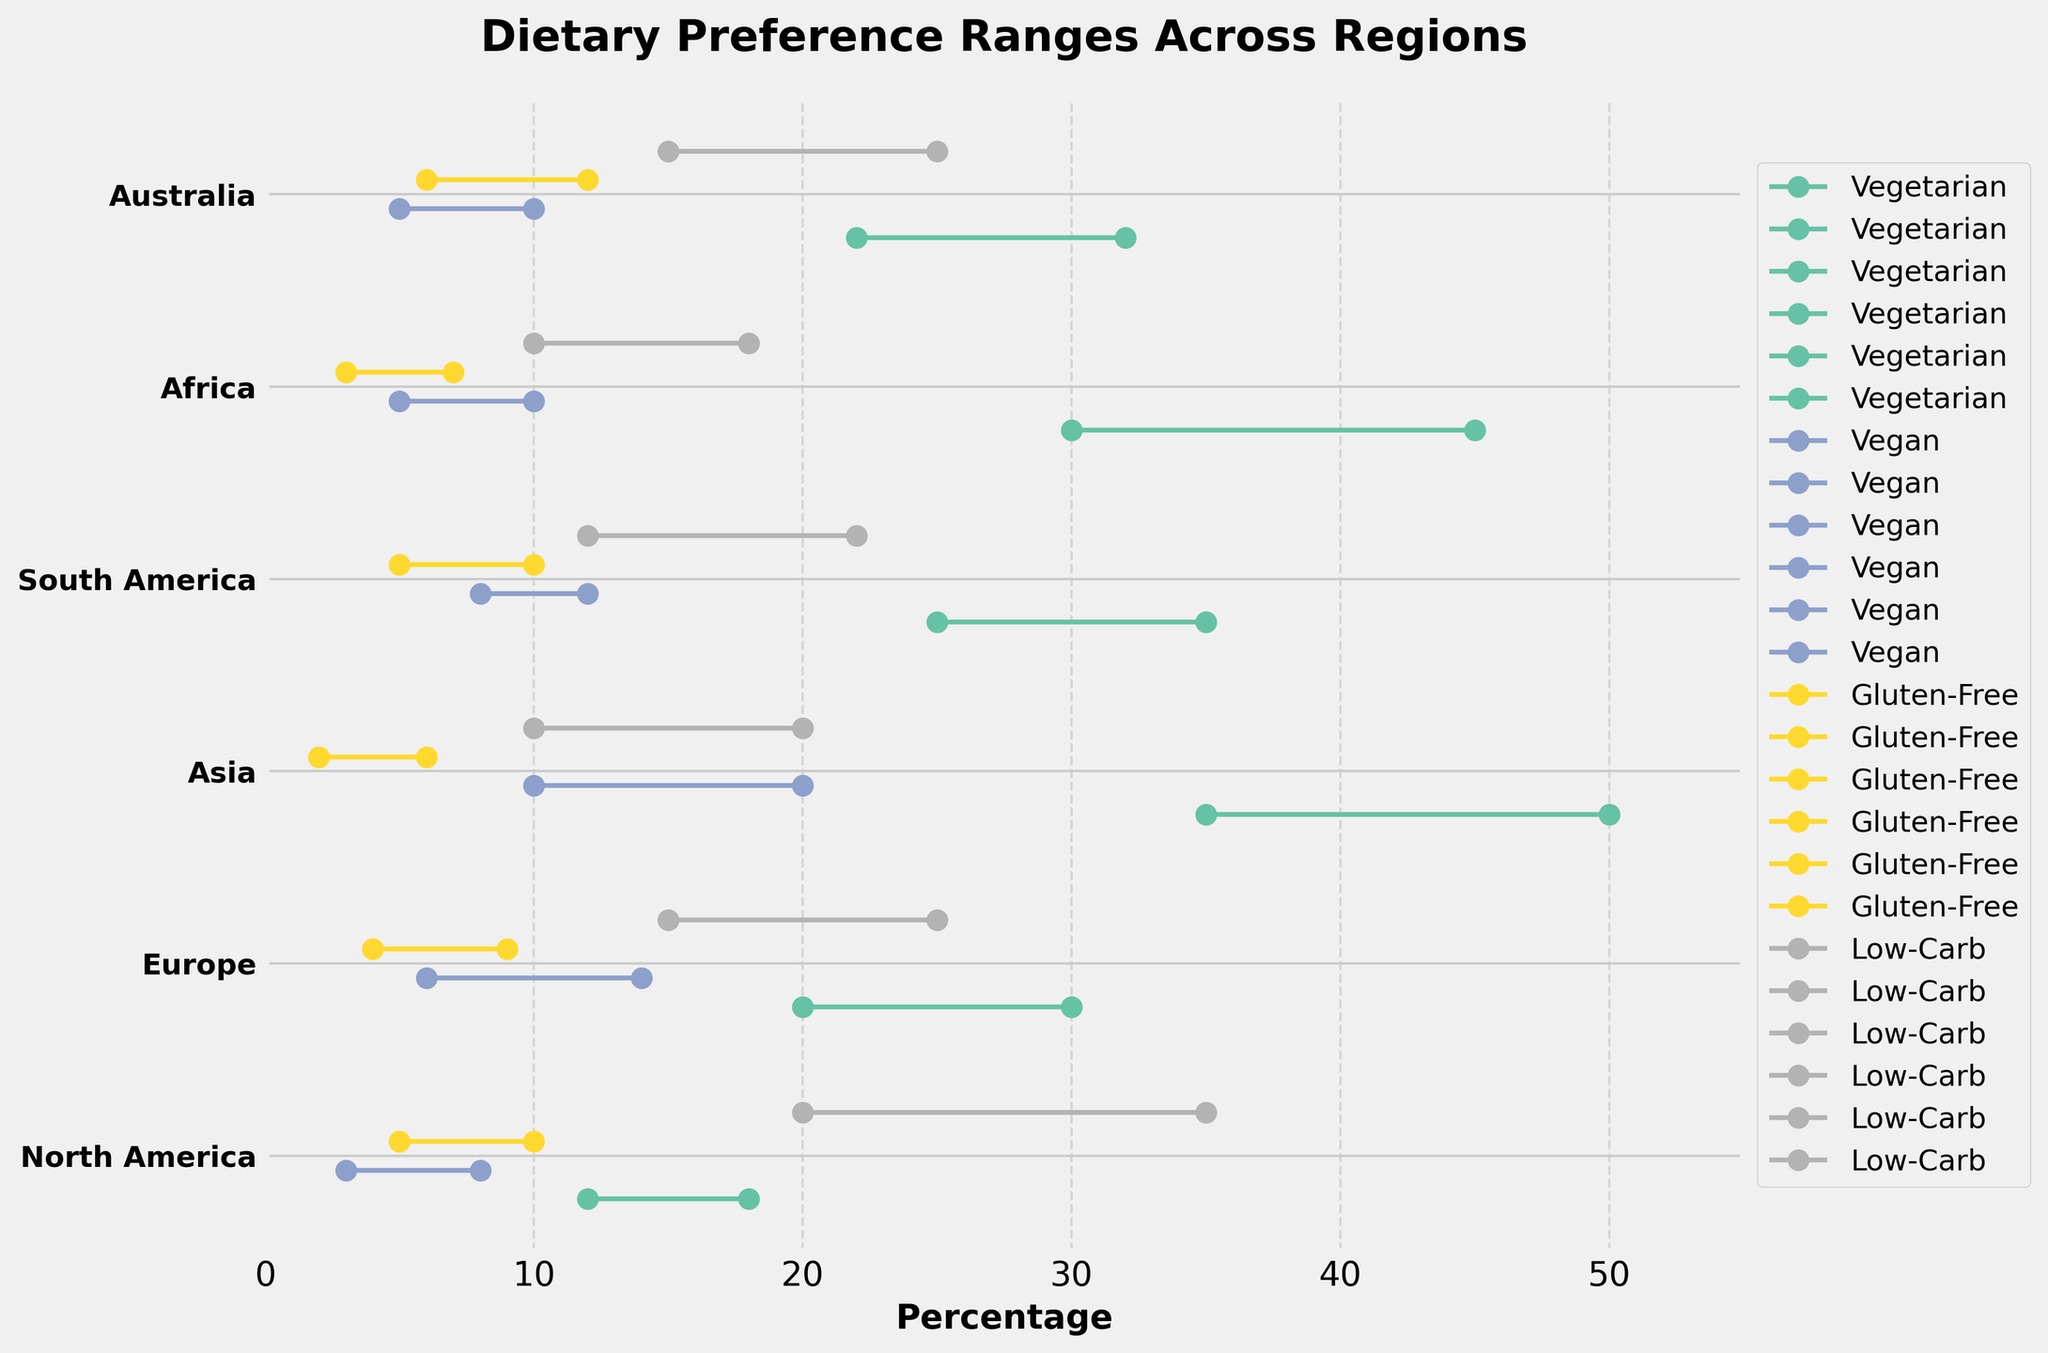What is the title of the plot? The title of the plot is located at the top and is typically the largest and boldest text on the image. This provides an overview of what the plot is about.
Answer: Dietary Preference Ranges Across Regions Which region has the highest maximum percentage for vegetarian dietary preferences? From the plot, take each region's dot plot section and compare the end point of the vegetarian preference bars. The bar in the Asia region ends at the highest percentage.
Answer: Asia What is the percentage range for gluten-free preferences in Europe? Locate the section of the plot corresponding to Europe. Identify the gluten-free row and read the minimum and maximum percentages indicated by the starting and ending points of the bar.
Answer: 4 to 9 How many dietary preferences are shown for each region? Count the distinct bars or lines for each region. Each region has a bar for vegetarian, vegan, gluten-free, and low-carb preferences.
Answer: 4 Which dietary preference shows the greatest max percentage in North America? Focus on the North America section and compare the end points of the bars for each dietary preference. Identify the preference with the highest number.
Answer: Low-Carb In which region is the minimum percentage for vegan preferences the same? Find the vegan preference bar for each region and compare the starting points of each bar. Identify regions that have the same minimum percentage for vegan preferences.
Answer: North America, Europe, Africa, Australia Calculate the average maximum percentage for low-carb preferences across all regions. Add up the maximum percentages for low-carb preferences from each region (35+25+20+22+18+25) and divide by the number of regions (6).
Answer: (35+25+20+22+18+25)/6 = 145/6 = 24.17 Which regions have a vegetarian preference range that exceeds 30% in their maximum value? For each region, check the maximum value of the vegetarian preference range and identify those that are greater than 30%.
Answer: Asia, Africa Which region shows the greatest difference in percentage range for vegan preferences? Calculate the difference between the minimum and maximum percentages for vegan preferences in each region and find the region with the largest gap.
Answer: Europe (14 - 6 = 8) Compare the minimum percentage values for gluten-free preferences in North America and Australia. Find the starting points of the gluten-free preference bars in both North America and Australia sections and compare the values.
Answer: Australia has a higher minimum percentage (6) than North America (5) 